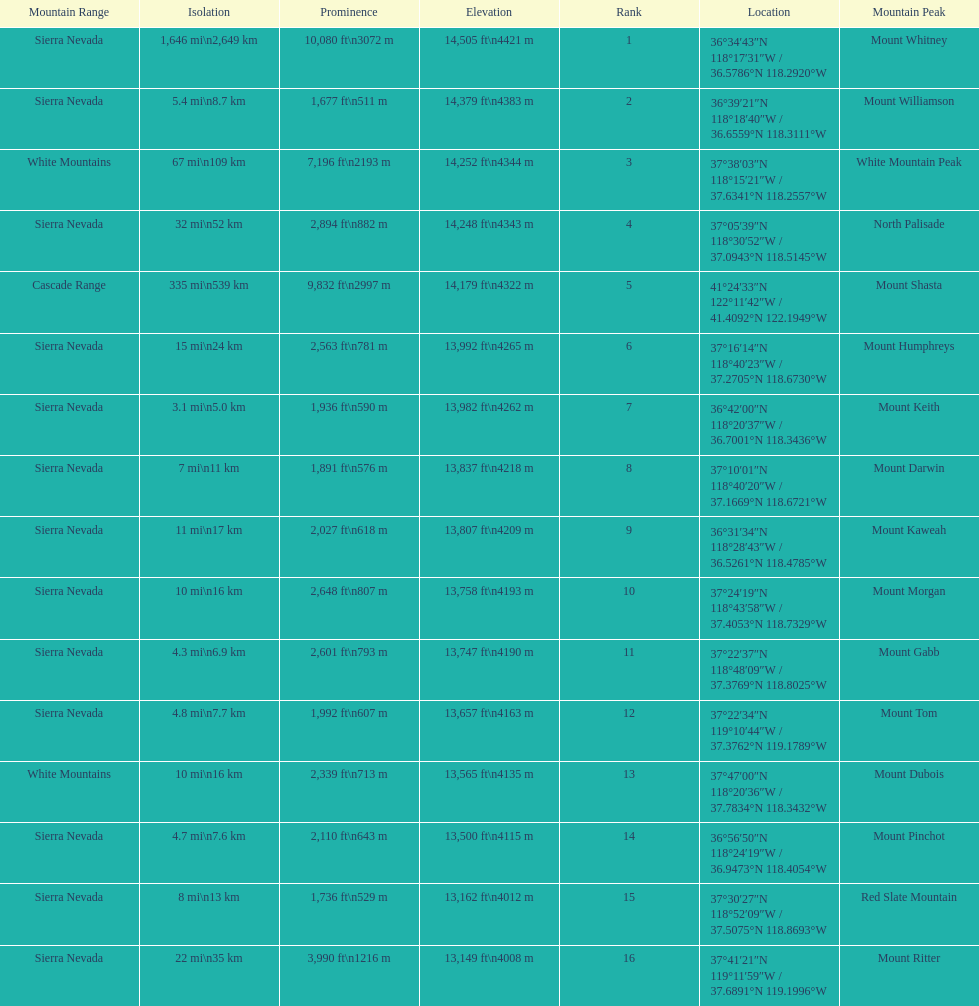Which mountain peak has a prominence more than 10,000 ft? Mount Whitney. 